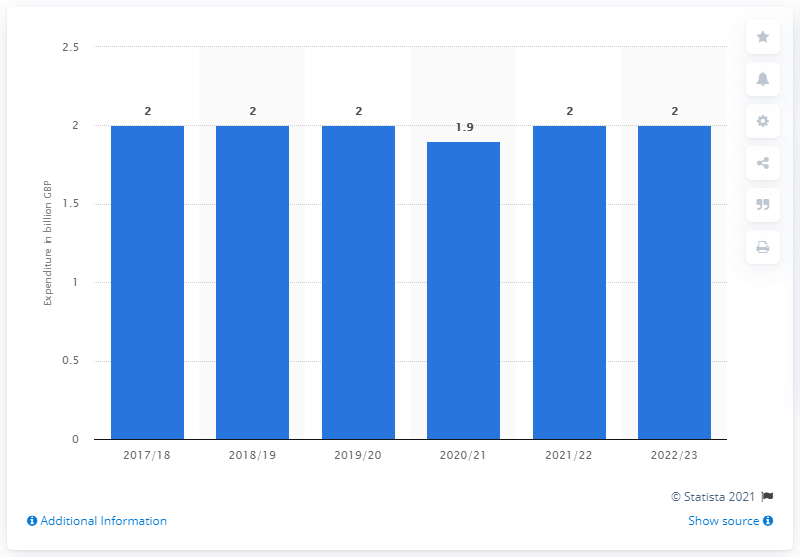Specify some key components in this picture. The expected expenditure for winter fuel payments is expected to drop by 1.9% from 2020/21. 